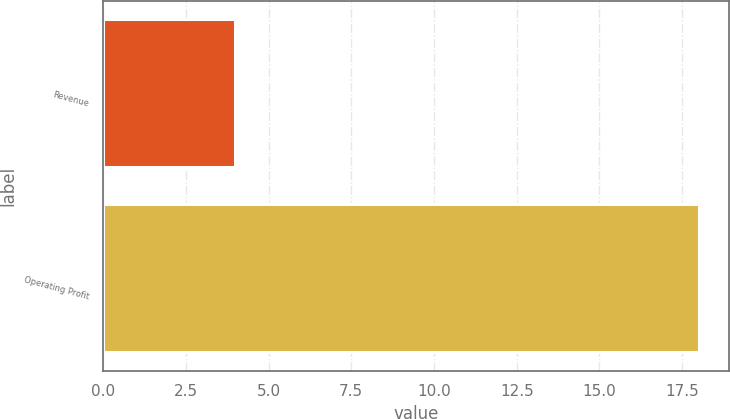Convert chart. <chart><loc_0><loc_0><loc_500><loc_500><bar_chart><fcel>Revenue<fcel>Operating Profit<nl><fcel>4<fcel>18<nl></chart> 